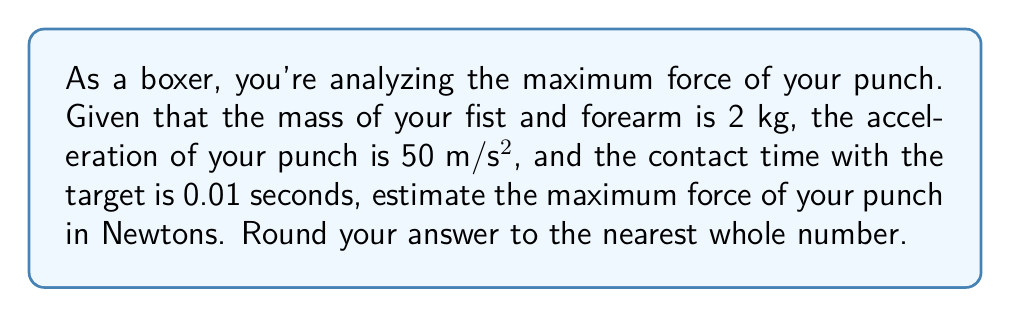Teach me how to tackle this problem. To solve this problem, we'll use Newton's Second Law of Motion and the concept of impulse. Let's break it down step-by-step:

1) First, we'll calculate the force using Newton's Second Law:
   $F = ma$
   Where:
   $m$ = mass of fist and forearm = 2 kg
   $a$ = acceleration = 50 m/s²

   $F = 2 \text{ kg} \times 50 \text{ m/s²} = 100 \text{ N}$

2) However, this is not the maximum force. The maximum force occurs during the impact, which is best described by the impulse-momentum theorem:

   $F_{\text{avg}} \times \Delta t = \Delta p$

   Where:
   $F_{\text{avg}}$ = average force during impact
   $\Delta t$ = contact time = 0.01 s
   $\Delta p$ = change in momentum

3) The change in momentum is equal to the final momentum minus the initial momentum:
   $\Delta p = mv_f - mv_i$
   
   Where $v_f$ is the final velocity (0 m/s, as the fist stops at impact) and $v_i$ is the initial velocity.

4) We can calculate the initial velocity using the equation:
   $v = at$
   $v = 50 \text{ m/s²} \times 0.01 \text{ s} = 0.5 \text{ m/s}$

5) Now we can calculate the change in momentum:
   $\Delta p = m(v_f - v_i) = 2 \text{ kg}(0 - 0.5 \text{ m/s}) = -1 \text{ kg·m/s}$

6) Substituting this into the impulse-momentum equation:
   $F_{\text{avg}} \times 0.01 \text{ s} = -1 \text{ kg·m/s}$

7) Solving for $F_{\text{avg}}$:
   $F_{\text{avg}} = \frac{-1 \text{ kg·m/s}}{0.01 \text{ s}} = -100 \text{ N}$

8) The negative sign indicates the direction of the force. The magnitude of the maximum force is 100 N.

Therefore, the maximum force of the punch is estimated to be 100 N.
Answer: 100 N 